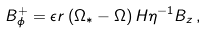<formula> <loc_0><loc_0><loc_500><loc_500>B _ { \phi } ^ { + } = \epsilon r \left ( \Omega _ { \ast } - \Omega \right ) H \eta ^ { - 1 } B _ { z } \, ,</formula> 